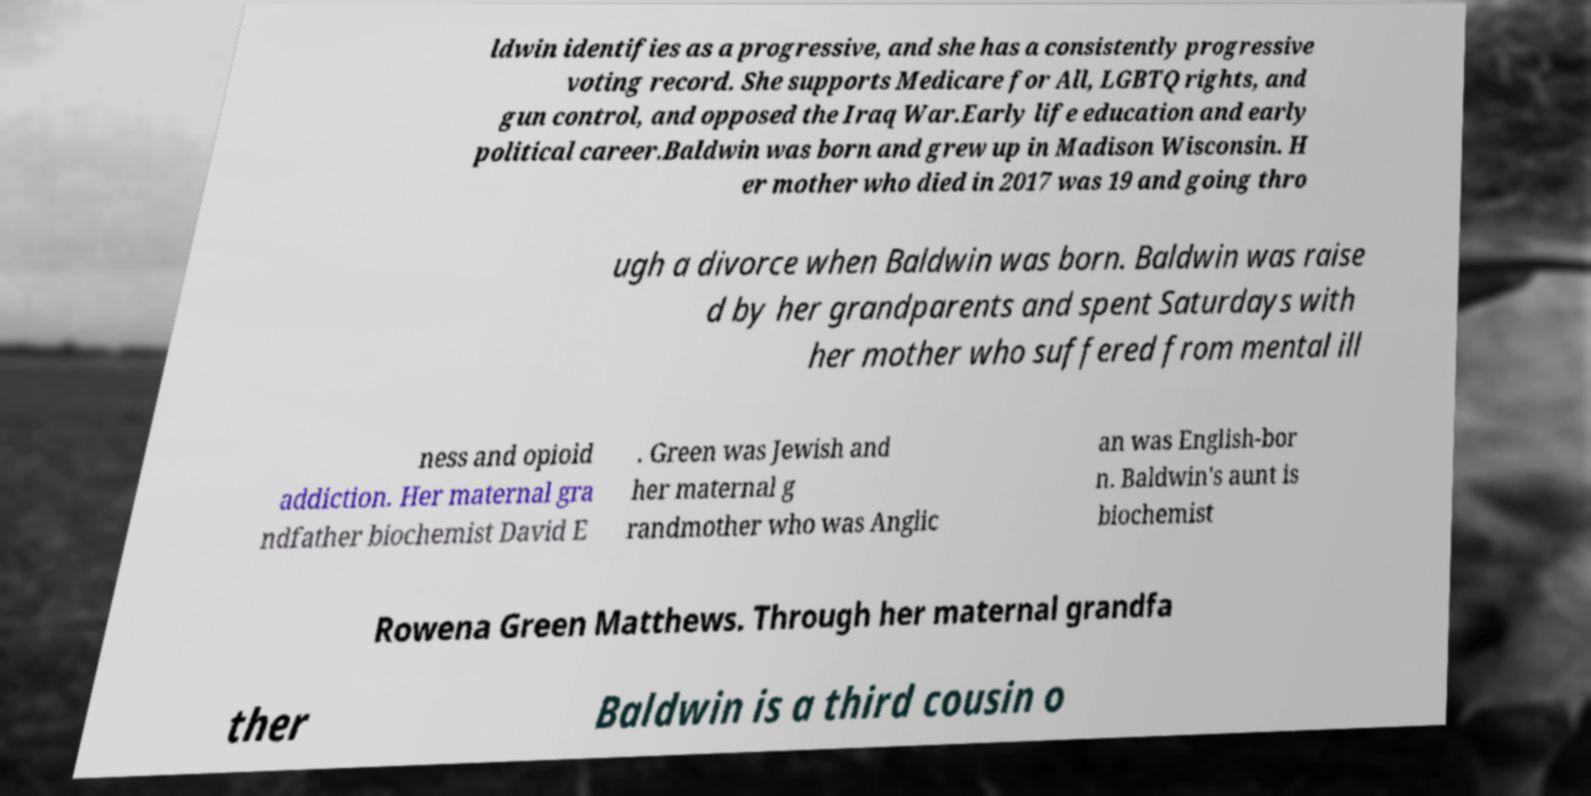For documentation purposes, I need the text within this image transcribed. Could you provide that? ldwin identifies as a progressive, and she has a consistently progressive voting record. She supports Medicare for All, LGBTQ rights, and gun control, and opposed the Iraq War.Early life education and early political career.Baldwin was born and grew up in Madison Wisconsin. H er mother who died in 2017 was 19 and going thro ugh a divorce when Baldwin was born. Baldwin was raise d by her grandparents and spent Saturdays with her mother who suffered from mental ill ness and opioid addiction. Her maternal gra ndfather biochemist David E . Green was Jewish and her maternal g randmother who was Anglic an was English-bor n. Baldwin's aunt is biochemist Rowena Green Matthews. Through her maternal grandfa ther Baldwin is a third cousin o 